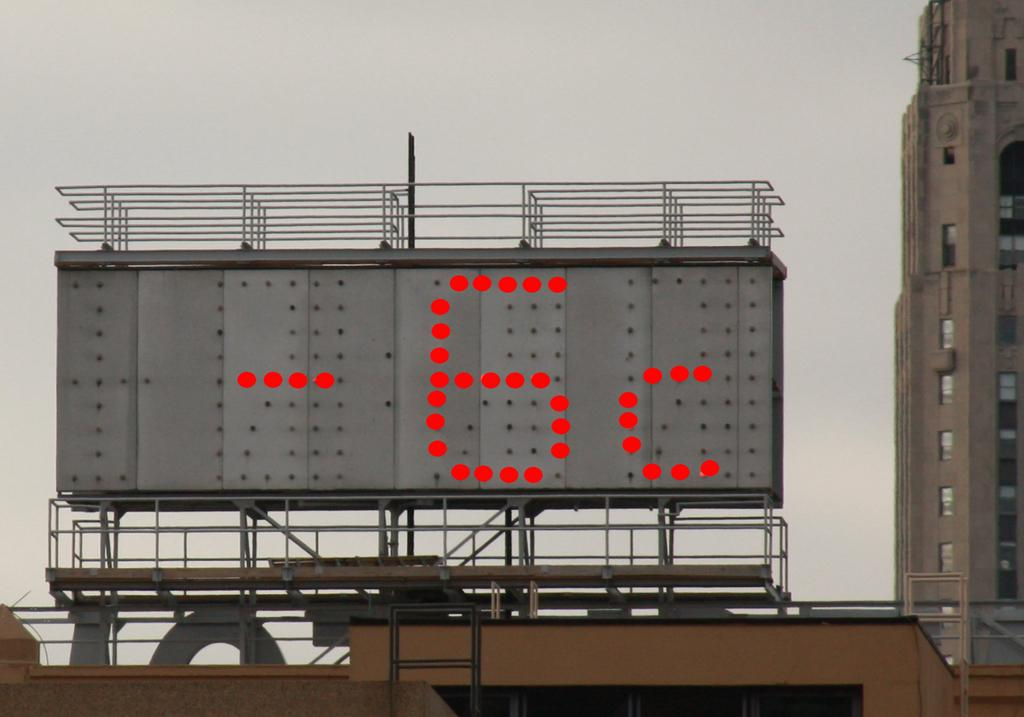<image>
Create a compact narrative representing the image presented. A Giant billboard shows current Temperature as -6c 